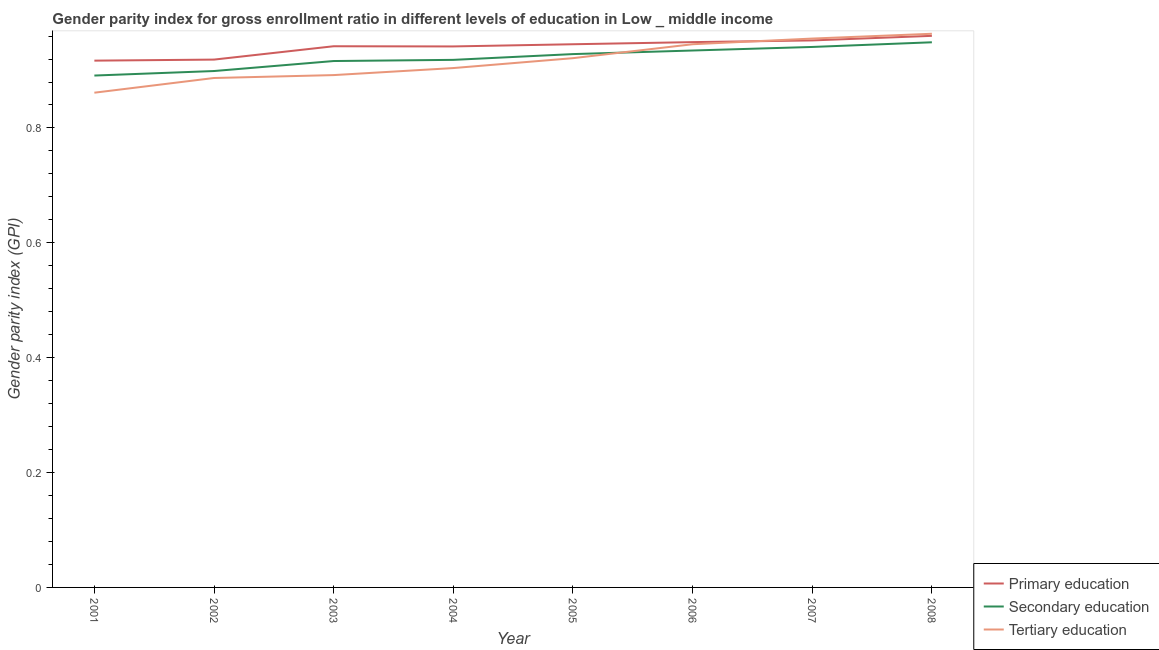Is the number of lines equal to the number of legend labels?
Your answer should be very brief. Yes. What is the gender parity index in secondary education in 2005?
Offer a terse response. 0.93. Across all years, what is the maximum gender parity index in tertiary education?
Ensure brevity in your answer.  0.96. Across all years, what is the minimum gender parity index in secondary education?
Your response must be concise. 0.89. What is the total gender parity index in primary education in the graph?
Your answer should be very brief. 7.53. What is the difference between the gender parity index in tertiary education in 2001 and that in 2006?
Your answer should be compact. -0.08. What is the difference between the gender parity index in primary education in 2004 and the gender parity index in tertiary education in 2005?
Give a very brief answer. 0.02. What is the average gender parity index in tertiary education per year?
Provide a short and direct response. 0.92. In the year 2007, what is the difference between the gender parity index in primary education and gender parity index in secondary education?
Make the answer very short. 0.01. In how many years, is the gender parity index in secondary education greater than 0.2?
Your response must be concise. 8. What is the ratio of the gender parity index in primary education in 2001 to that in 2008?
Your answer should be compact. 0.96. Is the gender parity index in secondary education in 2004 less than that in 2008?
Make the answer very short. Yes. What is the difference between the highest and the second highest gender parity index in primary education?
Your answer should be compact. 0.01. What is the difference between the highest and the lowest gender parity index in secondary education?
Your response must be concise. 0.06. In how many years, is the gender parity index in primary education greater than the average gender parity index in primary education taken over all years?
Ensure brevity in your answer.  6. Is the sum of the gender parity index in tertiary education in 2001 and 2005 greater than the maximum gender parity index in secondary education across all years?
Provide a short and direct response. Yes. Is it the case that in every year, the sum of the gender parity index in primary education and gender parity index in secondary education is greater than the gender parity index in tertiary education?
Your response must be concise. Yes. Is the gender parity index in secondary education strictly greater than the gender parity index in tertiary education over the years?
Offer a terse response. No. Is the gender parity index in tertiary education strictly less than the gender parity index in primary education over the years?
Offer a very short reply. No. How many lines are there?
Your answer should be very brief. 3. Are the values on the major ticks of Y-axis written in scientific E-notation?
Your answer should be very brief. No. Does the graph contain grids?
Your answer should be compact. No. Where does the legend appear in the graph?
Give a very brief answer. Bottom right. How are the legend labels stacked?
Provide a short and direct response. Vertical. What is the title of the graph?
Your response must be concise. Gender parity index for gross enrollment ratio in different levels of education in Low _ middle income. What is the label or title of the Y-axis?
Your answer should be very brief. Gender parity index (GPI). What is the Gender parity index (GPI) in Primary education in 2001?
Keep it short and to the point. 0.92. What is the Gender parity index (GPI) of Secondary education in 2001?
Keep it short and to the point. 0.89. What is the Gender parity index (GPI) of Tertiary education in 2001?
Your answer should be compact. 0.86. What is the Gender parity index (GPI) in Primary education in 2002?
Offer a terse response. 0.92. What is the Gender parity index (GPI) of Secondary education in 2002?
Make the answer very short. 0.9. What is the Gender parity index (GPI) in Tertiary education in 2002?
Make the answer very short. 0.89. What is the Gender parity index (GPI) in Primary education in 2003?
Provide a short and direct response. 0.94. What is the Gender parity index (GPI) in Secondary education in 2003?
Give a very brief answer. 0.92. What is the Gender parity index (GPI) of Tertiary education in 2003?
Your response must be concise. 0.89. What is the Gender parity index (GPI) of Primary education in 2004?
Make the answer very short. 0.94. What is the Gender parity index (GPI) in Secondary education in 2004?
Give a very brief answer. 0.92. What is the Gender parity index (GPI) in Tertiary education in 2004?
Your response must be concise. 0.9. What is the Gender parity index (GPI) in Primary education in 2005?
Ensure brevity in your answer.  0.95. What is the Gender parity index (GPI) of Secondary education in 2005?
Make the answer very short. 0.93. What is the Gender parity index (GPI) of Tertiary education in 2005?
Provide a short and direct response. 0.92. What is the Gender parity index (GPI) in Primary education in 2006?
Ensure brevity in your answer.  0.95. What is the Gender parity index (GPI) of Secondary education in 2006?
Ensure brevity in your answer.  0.93. What is the Gender parity index (GPI) of Tertiary education in 2006?
Your answer should be compact. 0.95. What is the Gender parity index (GPI) in Primary education in 2007?
Provide a succinct answer. 0.95. What is the Gender parity index (GPI) in Secondary education in 2007?
Your answer should be compact. 0.94. What is the Gender parity index (GPI) of Tertiary education in 2007?
Ensure brevity in your answer.  0.96. What is the Gender parity index (GPI) of Primary education in 2008?
Keep it short and to the point. 0.96. What is the Gender parity index (GPI) in Secondary education in 2008?
Provide a short and direct response. 0.95. What is the Gender parity index (GPI) in Tertiary education in 2008?
Offer a very short reply. 0.96. Across all years, what is the maximum Gender parity index (GPI) of Primary education?
Offer a terse response. 0.96. Across all years, what is the maximum Gender parity index (GPI) in Secondary education?
Provide a short and direct response. 0.95. Across all years, what is the maximum Gender parity index (GPI) of Tertiary education?
Your answer should be compact. 0.96. Across all years, what is the minimum Gender parity index (GPI) in Primary education?
Provide a short and direct response. 0.92. Across all years, what is the minimum Gender parity index (GPI) in Secondary education?
Ensure brevity in your answer.  0.89. Across all years, what is the minimum Gender parity index (GPI) in Tertiary education?
Your answer should be compact. 0.86. What is the total Gender parity index (GPI) of Primary education in the graph?
Give a very brief answer. 7.53. What is the total Gender parity index (GPI) of Secondary education in the graph?
Give a very brief answer. 7.38. What is the total Gender parity index (GPI) in Tertiary education in the graph?
Provide a short and direct response. 7.33. What is the difference between the Gender parity index (GPI) in Primary education in 2001 and that in 2002?
Make the answer very short. -0. What is the difference between the Gender parity index (GPI) in Secondary education in 2001 and that in 2002?
Keep it short and to the point. -0.01. What is the difference between the Gender parity index (GPI) in Tertiary education in 2001 and that in 2002?
Offer a very short reply. -0.03. What is the difference between the Gender parity index (GPI) in Primary education in 2001 and that in 2003?
Give a very brief answer. -0.03. What is the difference between the Gender parity index (GPI) of Secondary education in 2001 and that in 2003?
Your answer should be very brief. -0.03. What is the difference between the Gender parity index (GPI) in Tertiary education in 2001 and that in 2003?
Provide a short and direct response. -0.03. What is the difference between the Gender parity index (GPI) of Primary education in 2001 and that in 2004?
Give a very brief answer. -0.02. What is the difference between the Gender parity index (GPI) in Secondary education in 2001 and that in 2004?
Provide a succinct answer. -0.03. What is the difference between the Gender parity index (GPI) in Tertiary education in 2001 and that in 2004?
Offer a terse response. -0.04. What is the difference between the Gender parity index (GPI) of Primary education in 2001 and that in 2005?
Offer a very short reply. -0.03. What is the difference between the Gender parity index (GPI) in Secondary education in 2001 and that in 2005?
Offer a terse response. -0.04. What is the difference between the Gender parity index (GPI) in Tertiary education in 2001 and that in 2005?
Your answer should be compact. -0.06. What is the difference between the Gender parity index (GPI) of Primary education in 2001 and that in 2006?
Your answer should be very brief. -0.03. What is the difference between the Gender parity index (GPI) of Secondary education in 2001 and that in 2006?
Provide a succinct answer. -0.04. What is the difference between the Gender parity index (GPI) in Tertiary education in 2001 and that in 2006?
Offer a terse response. -0.08. What is the difference between the Gender parity index (GPI) of Primary education in 2001 and that in 2007?
Your answer should be very brief. -0.04. What is the difference between the Gender parity index (GPI) in Secondary education in 2001 and that in 2007?
Provide a succinct answer. -0.05. What is the difference between the Gender parity index (GPI) in Tertiary education in 2001 and that in 2007?
Your response must be concise. -0.09. What is the difference between the Gender parity index (GPI) in Primary education in 2001 and that in 2008?
Your response must be concise. -0.04. What is the difference between the Gender parity index (GPI) of Secondary education in 2001 and that in 2008?
Ensure brevity in your answer.  -0.06. What is the difference between the Gender parity index (GPI) in Tertiary education in 2001 and that in 2008?
Offer a very short reply. -0.1. What is the difference between the Gender parity index (GPI) of Primary education in 2002 and that in 2003?
Your response must be concise. -0.02. What is the difference between the Gender parity index (GPI) of Secondary education in 2002 and that in 2003?
Offer a very short reply. -0.02. What is the difference between the Gender parity index (GPI) of Tertiary education in 2002 and that in 2003?
Ensure brevity in your answer.  -0.01. What is the difference between the Gender parity index (GPI) in Primary education in 2002 and that in 2004?
Give a very brief answer. -0.02. What is the difference between the Gender parity index (GPI) in Secondary education in 2002 and that in 2004?
Your answer should be very brief. -0.02. What is the difference between the Gender parity index (GPI) of Tertiary education in 2002 and that in 2004?
Provide a succinct answer. -0.02. What is the difference between the Gender parity index (GPI) in Primary education in 2002 and that in 2005?
Ensure brevity in your answer.  -0.03. What is the difference between the Gender parity index (GPI) of Secondary education in 2002 and that in 2005?
Offer a very short reply. -0.03. What is the difference between the Gender parity index (GPI) of Tertiary education in 2002 and that in 2005?
Provide a succinct answer. -0.03. What is the difference between the Gender parity index (GPI) of Primary education in 2002 and that in 2006?
Keep it short and to the point. -0.03. What is the difference between the Gender parity index (GPI) in Secondary education in 2002 and that in 2006?
Ensure brevity in your answer.  -0.04. What is the difference between the Gender parity index (GPI) of Tertiary education in 2002 and that in 2006?
Give a very brief answer. -0.06. What is the difference between the Gender parity index (GPI) of Primary education in 2002 and that in 2007?
Your response must be concise. -0.03. What is the difference between the Gender parity index (GPI) of Secondary education in 2002 and that in 2007?
Your response must be concise. -0.04. What is the difference between the Gender parity index (GPI) in Tertiary education in 2002 and that in 2007?
Offer a very short reply. -0.07. What is the difference between the Gender parity index (GPI) of Primary education in 2002 and that in 2008?
Give a very brief answer. -0.04. What is the difference between the Gender parity index (GPI) in Secondary education in 2002 and that in 2008?
Your response must be concise. -0.05. What is the difference between the Gender parity index (GPI) of Tertiary education in 2002 and that in 2008?
Make the answer very short. -0.08. What is the difference between the Gender parity index (GPI) of Primary education in 2003 and that in 2004?
Provide a short and direct response. 0. What is the difference between the Gender parity index (GPI) in Secondary education in 2003 and that in 2004?
Provide a succinct answer. -0. What is the difference between the Gender parity index (GPI) in Tertiary education in 2003 and that in 2004?
Give a very brief answer. -0.01. What is the difference between the Gender parity index (GPI) in Primary education in 2003 and that in 2005?
Offer a very short reply. -0. What is the difference between the Gender parity index (GPI) of Secondary education in 2003 and that in 2005?
Offer a terse response. -0.01. What is the difference between the Gender parity index (GPI) of Tertiary education in 2003 and that in 2005?
Give a very brief answer. -0.03. What is the difference between the Gender parity index (GPI) in Primary education in 2003 and that in 2006?
Provide a short and direct response. -0.01. What is the difference between the Gender parity index (GPI) in Secondary education in 2003 and that in 2006?
Provide a succinct answer. -0.02. What is the difference between the Gender parity index (GPI) of Tertiary education in 2003 and that in 2006?
Your answer should be very brief. -0.05. What is the difference between the Gender parity index (GPI) of Primary education in 2003 and that in 2007?
Your answer should be very brief. -0.01. What is the difference between the Gender parity index (GPI) in Secondary education in 2003 and that in 2007?
Offer a very short reply. -0.02. What is the difference between the Gender parity index (GPI) of Tertiary education in 2003 and that in 2007?
Offer a terse response. -0.06. What is the difference between the Gender parity index (GPI) of Primary education in 2003 and that in 2008?
Provide a succinct answer. -0.02. What is the difference between the Gender parity index (GPI) of Secondary education in 2003 and that in 2008?
Your response must be concise. -0.03. What is the difference between the Gender parity index (GPI) of Tertiary education in 2003 and that in 2008?
Make the answer very short. -0.07. What is the difference between the Gender parity index (GPI) of Primary education in 2004 and that in 2005?
Offer a very short reply. -0. What is the difference between the Gender parity index (GPI) in Secondary education in 2004 and that in 2005?
Your answer should be compact. -0.01. What is the difference between the Gender parity index (GPI) in Tertiary education in 2004 and that in 2005?
Your response must be concise. -0.02. What is the difference between the Gender parity index (GPI) of Primary education in 2004 and that in 2006?
Offer a very short reply. -0.01. What is the difference between the Gender parity index (GPI) in Secondary education in 2004 and that in 2006?
Provide a short and direct response. -0.02. What is the difference between the Gender parity index (GPI) of Tertiary education in 2004 and that in 2006?
Your answer should be compact. -0.04. What is the difference between the Gender parity index (GPI) in Primary education in 2004 and that in 2007?
Offer a terse response. -0.01. What is the difference between the Gender parity index (GPI) in Secondary education in 2004 and that in 2007?
Keep it short and to the point. -0.02. What is the difference between the Gender parity index (GPI) of Tertiary education in 2004 and that in 2007?
Provide a short and direct response. -0.05. What is the difference between the Gender parity index (GPI) in Primary education in 2004 and that in 2008?
Your answer should be compact. -0.02. What is the difference between the Gender parity index (GPI) of Secondary education in 2004 and that in 2008?
Give a very brief answer. -0.03. What is the difference between the Gender parity index (GPI) of Tertiary education in 2004 and that in 2008?
Your answer should be very brief. -0.06. What is the difference between the Gender parity index (GPI) in Primary education in 2005 and that in 2006?
Your answer should be very brief. -0. What is the difference between the Gender parity index (GPI) of Secondary education in 2005 and that in 2006?
Ensure brevity in your answer.  -0.01. What is the difference between the Gender parity index (GPI) of Tertiary education in 2005 and that in 2006?
Give a very brief answer. -0.02. What is the difference between the Gender parity index (GPI) in Primary education in 2005 and that in 2007?
Your response must be concise. -0.01. What is the difference between the Gender parity index (GPI) in Secondary education in 2005 and that in 2007?
Provide a succinct answer. -0.01. What is the difference between the Gender parity index (GPI) of Tertiary education in 2005 and that in 2007?
Your answer should be very brief. -0.03. What is the difference between the Gender parity index (GPI) in Primary education in 2005 and that in 2008?
Your answer should be compact. -0.01. What is the difference between the Gender parity index (GPI) of Secondary education in 2005 and that in 2008?
Offer a very short reply. -0.02. What is the difference between the Gender parity index (GPI) of Tertiary education in 2005 and that in 2008?
Your response must be concise. -0.04. What is the difference between the Gender parity index (GPI) in Primary education in 2006 and that in 2007?
Provide a short and direct response. -0. What is the difference between the Gender parity index (GPI) in Secondary education in 2006 and that in 2007?
Give a very brief answer. -0.01. What is the difference between the Gender parity index (GPI) in Tertiary education in 2006 and that in 2007?
Your answer should be compact. -0.01. What is the difference between the Gender parity index (GPI) in Primary education in 2006 and that in 2008?
Offer a terse response. -0.01. What is the difference between the Gender parity index (GPI) of Secondary education in 2006 and that in 2008?
Your answer should be compact. -0.01. What is the difference between the Gender parity index (GPI) in Tertiary education in 2006 and that in 2008?
Make the answer very short. -0.02. What is the difference between the Gender parity index (GPI) in Primary education in 2007 and that in 2008?
Your answer should be compact. -0.01. What is the difference between the Gender parity index (GPI) of Secondary education in 2007 and that in 2008?
Ensure brevity in your answer.  -0.01. What is the difference between the Gender parity index (GPI) in Tertiary education in 2007 and that in 2008?
Ensure brevity in your answer.  -0.01. What is the difference between the Gender parity index (GPI) in Primary education in 2001 and the Gender parity index (GPI) in Secondary education in 2002?
Make the answer very short. 0.02. What is the difference between the Gender parity index (GPI) in Primary education in 2001 and the Gender parity index (GPI) in Tertiary education in 2002?
Ensure brevity in your answer.  0.03. What is the difference between the Gender parity index (GPI) of Secondary education in 2001 and the Gender parity index (GPI) of Tertiary education in 2002?
Your response must be concise. 0. What is the difference between the Gender parity index (GPI) of Primary education in 2001 and the Gender parity index (GPI) of Secondary education in 2003?
Give a very brief answer. 0. What is the difference between the Gender parity index (GPI) of Primary education in 2001 and the Gender parity index (GPI) of Tertiary education in 2003?
Your answer should be compact. 0.03. What is the difference between the Gender parity index (GPI) of Secondary education in 2001 and the Gender parity index (GPI) of Tertiary education in 2003?
Your answer should be compact. -0. What is the difference between the Gender parity index (GPI) in Primary education in 2001 and the Gender parity index (GPI) in Secondary education in 2004?
Your answer should be very brief. -0. What is the difference between the Gender parity index (GPI) in Primary education in 2001 and the Gender parity index (GPI) in Tertiary education in 2004?
Keep it short and to the point. 0.01. What is the difference between the Gender parity index (GPI) in Secondary education in 2001 and the Gender parity index (GPI) in Tertiary education in 2004?
Your answer should be very brief. -0.01. What is the difference between the Gender parity index (GPI) of Primary education in 2001 and the Gender parity index (GPI) of Secondary education in 2005?
Provide a short and direct response. -0.01. What is the difference between the Gender parity index (GPI) of Primary education in 2001 and the Gender parity index (GPI) of Tertiary education in 2005?
Your answer should be compact. -0. What is the difference between the Gender parity index (GPI) in Secondary education in 2001 and the Gender parity index (GPI) in Tertiary education in 2005?
Your answer should be very brief. -0.03. What is the difference between the Gender parity index (GPI) of Primary education in 2001 and the Gender parity index (GPI) of Secondary education in 2006?
Your answer should be very brief. -0.02. What is the difference between the Gender parity index (GPI) of Primary education in 2001 and the Gender parity index (GPI) of Tertiary education in 2006?
Provide a short and direct response. -0.03. What is the difference between the Gender parity index (GPI) of Secondary education in 2001 and the Gender parity index (GPI) of Tertiary education in 2006?
Your answer should be very brief. -0.05. What is the difference between the Gender parity index (GPI) of Primary education in 2001 and the Gender parity index (GPI) of Secondary education in 2007?
Offer a very short reply. -0.02. What is the difference between the Gender parity index (GPI) in Primary education in 2001 and the Gender parity index (GPI) in Tertiary education in 2007?
Provide a succinct answer. -0.04. What is the difference between the Gender parity index (GPI) of Secondary education in 2001 and the Gender parity index (GPI) of Tertiary education in 2007?
Your answer should be compact. -0.06. What is the difference between the Gender parity index (GPI) of Primary education in 2001 and the Gender parity index (GPI) of Secondary education in 2008?
Keep it short and to the point. -0.03. What is the difference between the Gender parity index (GPI) of Primary education in 2001 and the Gender parity index (GPI) of Tertiary education in 2008?
Provide a short and direct response. -0.05. What is the difference between the Gender parity index (GPI) of Secondary education in 2001 and the Gender parity index (GPI) of Tertiary education in 2008?
Make the answer very short. -0.07. What is the difference between the Gender parity index (GPI) in Primary education in 2002 and the Gender parity index (GPI) in Secondary education in 2003?
Your response must be concise. 0. What is the difference between the Gender parity index (GPI) in Primary education in 2002 and the Gender parity index (GPI) in Tertiary education in 2003?
Provide a succinct answer. 0.03. What is the difference between the Gender parity index (GPI) in Secondary education in 2002 and the Gender parity index (GPI) in Tertiary education in 2003?
Your response must be concise. 0.01. What is the difference between the Gender parity index (GPI) of Primary education in 2002 and the Gender parity index (GPI) of Secondary education in 2004?
Keep it short and to the point. 0. What is the difference between the Gender parity index (GPI) in Primary education in 2002 and the Gender parity index (GPI) in Tertiary education in 2004?
Provide a short and direct response. 0.01. What is the difference between the Gender parity index (GPI) of Secondary education in 2002 and the Gender parity index (GPI) of Tertiary education in 2004?
Your answer should be very brief. -0.01. What is the difference between the Gender parity index (GPI) of Primary education in 2002 and the Gender parity index (GPI) of Secondary education in 2005?
Your answer should be compact. -0.01. What is the difference between the Gender parity index (GPI) of Primary education in 2002 and the Gender parity index (GPI) of Tertiary education in 2005?
Keep it short and to the point. -0. What is the difference between the Gender parity index (GPI) in Secondary education in 2002 and the Gender parity index (GPI) in Tertiary education in 2005?
Provide a short and direct response. -0.02. What is the difference between the Gender parity index (GPI) of Primary education in 2002 and the Gender parity index (GPI) of Secondary education in 2006?
Your answer should be very brief. -0.02. What is the difference between the Gender parity index (GPI) in Primary education in 2002 and the Gender parity index (GPI) in Tertiary education in 2006?
Provide a succinct answer. -0.03. What is the difference between the Gender parity index (GPI) of Secondary education in 2002 and the Gender parity index (GPI) of Tertiary education in 2006?
Your response must be concise. -0.05. What is the difference between the Gender parity index (GPI) in Primary education in 2002 and the Gender parity index (GPI) in Secondary education in 2007?
Make the answer very short. -0.02. What is the difference between the Gender parity index (GPI) of Primary education in 2002 and the Gender parity index (GPI) of Tertiary education in 2007?
Offer a terse response. -0.04. What is the difference between the Gender parity index (GPI) of Secondary education in 2002 and the Gender parity index (GPI) of Tertiary education in 2007?
Your answer should be compact. -0.06. What is the difference between the Gender parity index (GPI) in Primary education in 2002 and the Gender parity index (GPI) in Secondary education in 2008?
Provide a succinct answer. -0.03. What is the difference between the Gender parity index (GPI) in Primary education in 2002 and the Gender parity index (GPI) in Tertiary education in 2008?
Give a very brief answer. -0.04. What is the difference between the Gender parity index (GPI) in Secondary education in 2002 and the Gender parity index (GPI) in Tertiary education in 2008?
Provide a short and direct response. -0.06. What is the difference between the Gender parity index (GPI) of Primary education in 2003 and the Gender parity index (GPI) of Secondary education in 2004?
Make the answer very short. 0.02. What is the difference between the Gender parity index (GPI) of Primary education in 2003 and the Gender parity index (GPI) of Tertiary education in 2004?
Make the answer very short. 0.04. What is the difference between the Gender parity index (GPI) in Secondary education in 2003 and the Gender parity index (GPI) in Tertiary education in 2004?
Offer a very short reply. 0.01. What is the difference between the Gender parity index (GPI) of Primary education in 2003 and the Gender parity index (GPI) of Secondary education in 2005?
Your answer should be compact. 0.01. What is the difference between the Gender parity index (GPI) of Primary education in 2003 and the Gender parity index (GPI) of Tertiary education in 2005?
Provide a succinct answer. 0.02. What is the difference between the Gender parity index (GPI) in Secondary education in 2003 and the Gender parity index (GPI) in Tertiary education in 2005?
Make the answer very short. -0.01. What is the difference between the Gender parity index (GPI) in Primary education in 2003 and the Gender parity index (GPI) in Secondary education in 2006?
Provide a succinct answer. 0.01. What is the difference between the Gender parity index (GPI) in Primary education in 2003 and the Gender parity index (GPI) in Tertiary education in 2006?
Your answer should be very brief. -0. What is the difference between the Gender parity index (GPI) of Secondary education in 2003 and the Gender parity index (GPI) of Tertiary education in 2006?
Ensure brevity in your answer.  -0.03. What is the difference between the Gender parity index (GPI) of Primary education in 2003 and the Gender parity index (GPI) of Secondary education in 2007?
Offer a very short reply. 0. What is the difference between the Gender parity index (GPI) in Primary education in 2003 and the Gender parity index (GPI) in Tertiary education in 2007?
Keep it short and to the point. -0.01. What is the difference between the Gender parity index (GPI) in Secondary education in 2003 and the Gender parity index (GPI) in Tertiary education in 2007?
Make the answer very short. -0.04. What is the difference between the Gender parity index (GPI) in Primary education in 2003 and the Gender parity index (GPI) in Secondary education in 2008?
Ensure brevity in your answer.  -0.01. What is the difference between the Gender parity index (GPI) of Primary education in 2003 and the Gender parity index (GPI) of Tertiary education in 2008?
Offer a terse response. -0.02. What is the difference between the Gender parity index (GPI) in Secondary education in 2003 and the Gender parity index (GPI) in Tertiary education in 2008?
Give a very brief answer. -0.05. What is the difference between the Gender parity index (GPI) of Primary education in 2004 and the Gender parity index (GPI) of Secondary education in 2005?
Your response must be concise. 0.01. What is the difference between the Gender parity index (GPI) in Primary education in 2004 and the Gender parity index (GPI) in Tertiary education in 2005?
Offer a very short reply. 0.02. What is the difference between the Gender parity index (GPI) in Secondary education in 2004 and the Gender parity index (GPI) in Tertiary education in 2005?
Provide a succinct answer. -0. What is the difference between the Gender parity index (GPI) of Primary education in 2004 and the Gender parity index (GPI) of Secondary education in 2006?
Ensure brevity in your answer.  0.01. What is the difference between the Gender parity index (GPI) in Primary education in 2004 and the Gender parity index (GPI) in Tertiary education in 2006?
Make the answer very short. -0. What is the difference between the Gender parity index (GPI) of Secondary education in 2004 and the Gender parity index (GPI) of Tertiary education in 2006?
Provide a short and direct response. -0.03. What is the difference between the Gender parity index (GPI) of Primary education in 2004 and the Gender parity index (GPI) of Secondary education in 2007?
Keep it short and to the point. 0. What is the difference between the Gender parity index (GPI) in Primary education in 2004 and the Gender parity index (GPI) in Tertiary education in 2007?
Give a very brief answer. -0.01. What is the difference between the Gender parity index (GPI) of Secondary education in 2004 and the Gender parity index (GPI) of Tertiary education in 2007?
Make the answer very short. -0.04. What is the difference between the Gender parity index (GPI) in Primary education in 2004 and the Gender parity index (GPI) in Secondary education in 2008?
Provide a succinct answer. -0.01. What is the difference between the Gender parity index (GPI) of Primary education in 2004 and the Gender parity index (GPI) of Tertiary education in 2008?
Your answer should be very brief. -0.02. What is the difference between the Gender parity index (GPI) in Secondary education in 2004 and the Gender parity index (GPI) in Tertiary education in 2008?
Provide a succinct answer. -0.05. What is the difference between the Gender parity index (GPI) of Primary education in 2005 and the Gender parity index (GPI) of Secondary education in 2006?
Make the answer very short. 0.01. What is the difference between the Gender parity index (GPI) in Secondary education in 2005 and the Gender parity index (GPI) in Tertiary education in 2006?
Provide a succinct answer. -0.02. What is the difference between the Gender parity index (GPI) in Primary education in 2005 and the Gender parity index (GPI) in Secondary education in 2007?
Provide a succinct answer. 0. What is the difference between the Gender parity index (GPI) of Primary education in 2005 and the Gender parity index (GPI) of Tertiary education in 2007?
Your answer should be very brief. -0.01. What is the difference between the Gender parity index (GPI) of Secondary education in 2005 and the Gender parity index (GPI) of Tertiary education in 2007?
Offer a terse response. -0.03. What is the difference between the Gender parity index (GPI) of Primary education in 2005 and the Gender parity index (GPI) of Secondary education in 2008?
Your answer should be compact. -0. What is the difference between the Gender parity index (GPI) of Primary education in 2005 and the Gender parity index (GPI) of Tertiary education in 2008?
Provide a succinct answer. -0.02. What is the difference between the Gender parity index (GPI) in Secondary education in 2005 and the Gender parity index (GPI) in Tertiary education in 2008?
Offer a very short reply. -0.04. What is the difference between the Gender parity index (GPI) of Primary education in 2006 and the Gender parity index (GPI) of Secondary education in 2007?
Ensure brevity in your answer.  0.01. What is the difference between the Gender parity index (GPI) in Primary education in 2006 and the Gender parity index (GPI) in Tertiary education in 2007?
Your answer should be compact. -0.01. What is the difference between the Gender parity index (GPI) in Secondary education in 2006 and the Gender parity index (GPI) in Tertiary education in 2007?
Offer a terse response. -0.02. What is the difference between the Gender parity index (GPI) of Primary education in 2006 and the Gender parity index (GPI) of Tertiary education in 2008?
Your response must be concise. -0.01. What is the difference between the Gender parity index (GPI) of Secondary education in 2006 and the Gender parity index (GPI) of Tertiary education in 2008?
Your answer should be very brief. -0.03. What is the difference between the Gender parity index (GPI) in Primary education in 2007 and the Gender parity index (GPI) in Secondary education in 2008?
Give a very brief answer. 0. What is the difference between the Gender parity index (GPI) of Primary education in 2007 and the Gender parity index (GPI) of Tertiary education in 2008?
Keep it short and to the point. -0.01. What is the difference between the Gender parity index (GPI) in Secondary education in 2007 and the Gender parity index (GPI) in Tertiary education in 2008?
Ensure brevity in your answer.  -0.02. What is the average Gender parity index (GPI) of Primary education per year?
Keep it short and to the point. 0.94. What is the average Gender parity index (GPI) in Secondary education per year?
Offer a very short reply. 0.92. What is the average Gender parity index (GPI) of Tertiary education per year?
Ensure brevity in your answer.  0.92. In the year 2001, what is the difference between the Gender parity index (GPI) of Primary education and Gender parity index (GPI) of Secondary education?
Provide a succinct answer. 0.03. In the year 2001, what is the difference between the Gender parity index (GPI) in Primary education and Gender parity index (GPI) in Tertiary education?
Your response must be concise. 0.06. In the year 2001, what is the difference between the Gender parity index (GPI) in Secondary education and Gender parity index (GPI) in Tertiary education?
Your answer should be very brief. 0.03. In the year 2002, what is the difference between the Gender parity index (GPI) of Primary education and Gender parity index (GPI) of Secondary education?
Your response must be concise. 0.02. In the year 2002, what is the difference between the Gender parity index (GPI) of Primary education and Gender parity index (GPI) of Tertiary education?
Provide a succinct answer. 0.03. In the year 2002, what is the difference between the Gender parity index (GPI) in Secondary education and Gender parity index (GPI) in Tertiary education?
Offer a terse response. 0.01. In the year 2003, what is the difference between the Gender parity index (GPI) in Primary education and Gender parity index (GPI) in Secondary education?
Provide a succinct answer. 0.03. In the year 2003, what is the difference between the Gender parity index (GPI) of Primary education and Gender parity index (GPI) of Tertiary education?
Offer a very short reply. 0.05. In the year 2003, what is the difference between the Gender parity index (GPI) of Secondary education and Gender parity index (GPI) of Tertiary education?
Keep it short and to the point. 0.02. In the year 2004, what is the difference between the Gender parity index (GPI) of Primary education and Gender parity index (GPI) of Secondary education?
Provide a succinct answer. 0.02. In the year 2004, what is the difference between the Gender parity index (GPI) in Primary education and Gender parity index (GPI) in Tertiary education?
Offer a very short reply. 0.04. In the year 2004, what is the difference between the Gender parity index (GPI) of Secondary education and Gender parity index (GPI) of Tertiary education?
Provide a succinct answer. 0.01. In the year 2005, what is the difference between the Gender parity index (GPI) in Primary education and Gender parity index (GPI) in Secondary education?
Ensure brevity in your answer.  0.02. In the year 2005, what is the difference between the Gender parity index (GPI) in Primary education and Gender parity index (GPI) in Tertiary education?
Your answer should be very brief. 0.02. In the year 2005, what is the difference between the Gender parity index (GPI) of Secondary education and Gender parity index (GPI) of Tertiary education?
Make the answer very short. 0.01. In the year 2006, what is the difference between the Gender parity index (GPI) of Primary education and Gender parity index (GPI) of Secondary education?
Offer a terse response. 0.01. In the year 2006, what is the difference between the Gender parity index (GPI) of Primary education and Gender parity index (GPI) of Tertiary education?
Ensure brevity in your answer.  0. In the year 2006, what is the difference between the Gender parity index (GPI) of Secondary education and Gender parity index (GPI) of Tertiary education?
Your response must be concise. -0.01. In the year 2007, what is the difference between the Gender parity index (GPI) in Primary education and Gender parity index (GPI) in Secondary education?
Give a very brief answer. 0.01. In the year 2007, what is the difference between the Gender parity index (GPI) in Primary education and Gender parity index (GPI) in Tertiary education?
Ensure brevity in your answer.  -0. In the year 2007, what is the difference between the Gender parity index (GPI) of Secondary education and Gender parity index (GPI) of Tertiary education?
Your response must be concise. -0.01. In the year 2008, what is the difference between the Gender parity index (GPI) in Primary education and Gender parity index (GPI) in Secondary education?
Your answer should be very brief. 0.01. In the year 2008, what is the difference between the Gender parity index (GPI) of Primary education and Gender parity index (GPI) of Tertiary education?
Provide a succinct answer. -0. In the year 2008, what is the difference between the Gender parity index (GPI) of Secondary education and Gender parity index (GPI) of Tertiary education?
Offer a very short reply. -0.01. What is the ratio of the Gender parity index (GPI) in Secondary education in 2001 to that in 2002?
Your response must be concise. 0.99. What is the ratio of the Gender parity index (GPI) in Tertiary education in 2001 to that in 2002?
Offer a very short reply. 0.97. What is the ratio of the Gender parity index (GPI) in Primary education in 2001 to that in 2003?
Your response must be concise. 0.97. What is the ratio of the Gender parity index (GPI) of Secondary education in 2001 to that in 2003?
Offer a terse response. 0.97. What is the ratio of the Gender parity index (GPI) of Tertiary education in 2001 to that in 2003?
Provide a short and direct response. 0.97. What is the ratio of the Gender parity index (GPI) in Primary education in 2001 to that in 2004?
Provide a short and direct response. 0.97. What is the ratio of the Gender parity index (GPI) of Secondary education in 2001 to that in 2004?
Your answer should be compact. 0.97. What is the ratio of the Gender parity index (GPI) of Tertiary education in 2001 to that in 2004?
Your response must be concise. 0.95. What is the ratio of the Gender parity index (GPI) of Primary education in 2001 to that in 2005?
Provide a short and direct response. 0.97. What is the ratio of the Gender parity index (GPI) in Secondary education in 2001 to that in 2005?
Give a very brief answer. 0.96. What is the ratio of the Gender parity index (GPI) of Tertiary education in 2001 to that in 2005?
Your response must be concise. 0.93. What is the ratio of the Gender parity index (GPI) of Secondary education in 2001 to that in 2006?
Offer a terse response. 0.95. What is the ratio of the Gender parity index (GPI) in Tertiary education in 2001 to that in 2006?
Provide a short and direct response. 0.91. What is the ratio of the Gender parity index (GPI) in Primary education in 2001 to that in 2007?
Provide a short and direct response. 0.96. What is the ratio of the Gender parity index (GPI) of Secondary education in 2001 to that in 2007?
Offer a very short reply. 0.95. What is the ratio of the Gender parity index (GPI) in Tertiary education in 2001 to that in 2007?
Ensure brevity in your answer.  0.9. What is the ratio of the Gender parity index (GPI) in Primary education in 2001 to that in 2008?
Provide a short and direct response. 0.95. What is the ratio of the Gender parity index (GPI) of Secondary education in 2001 to that in 2008?
Your answer should be compact. 0.94. What is the ratio of the Gender parity index (GPI) of Tertiary education in 2001 to that in 2008?
Offer a terse response. 0.89. What is the ratio of the Gender parity index (GPI) in Primary education in 2002 to that in 2003?
Your answer should be compact. 0.98. What is the ratio of the Gender parity index (GPI) in Secondary education in 2002 to that in 2003?
Give a very brief answer. 0.98. What is the ratio of the Gender parity index (GPI) of Primary education in 2002 to that in 2004?
Provide a short and direct response. 0.98. What is the ratio of the Gender parity index (GPI) in Secondary education in 2002 to that in 2004?
Your answer should be very brief. 0.98. What is the ratio of the Gender parity index (GPI) of Tertiary education in 2002 to that in 2004?
Provide a short and direct response. 0.98. What is the ratio of the Gender parity index (GPI) in Primary education in 2002 to that in 2005?
Ensure brevity in your answer.  0.97. What is the ratio of the Gender parity index (GPI) in Secondary education in 2002 to that in 2005?
Offer a very short reply. 0.97. What is the ratio of the Gender parity index (GPI) in Tertiary education in 2002 to that in 2005?
Ensure brevity in your answer.  0.96. What is the ratio of the Gender parity index (GPI) of Primary education in 2002 to that in 2006?
Keep it short and to the point. 0.97. What is the ratio of the Gender parity index (GPI) of Secondary education in 2002 to that in 2006?
Make the answer very short. 0.96. What is the ratio of the Gender parity index (GPI) of Tertiary education in 2002 to that in 2006?
Provide a short and direct response. 0.94. What is the ratio of the Gender parity index (GPI) in Primary education in 2002 to that in 2007?
Offer a terse response. 0.96. What is the ratio of the Gender parity index (GPI) in Secondary education in 2002 to that in 2007?
Your response must be concise. 0.96. What is the ratio of the Gender parity index (GPI) of Tertiary education in 2002 to that in 2007?
Give a very brief answer. 0.93. What is the ratio of the Gender parity index (GPI) in Primary education in 2002 to that in 2008?
Your response must be concise. 0.96. What is the ratio of the Gender parity index (GPI) in Secondary education in 2002 to that in 2008?
Provide a short and direct response. 0.95. What is the ratio of the Gender parity index (GPI) in Tertiary education in 2002 to that in 2008?
Offer a terse response. 0.92. What is the ratio of the Gender parity index (GPI) in Secondary education in 2003 to that in 2004?
Provide a succinct answer. 1. What is the ratio of the Gender parity index (GPI) in Tertiary education in 2003 to that in 2004?
Your answer should be compact. 0.99. What is the ratio of the Gender parity index (GPI) of Primary education in 2003 to that in 2005?
Your response must be concise. 1. What is the ratio of the Gender parity index (GPI) of Secondary education in 2003 to that in 2006?
Provide a short and direct response. 0.98. What is the ratio of the Gender parity index (GPI) in Tertiary education in 2003 to that in 2006?
Offer a terse response. 0.94. What is the ratio of the Gender parity index (GPI) in Secondary education in 2003 to that in 2007?
Offer a terse response. 0.97. What is the ratio of the Gender parity index (GPI) of Tertiary education in 2003 to that in 2007?
Offer a terse response. 0.93. What is the ratio of the Gender parity index (GPI) in Primary education in 2003 to that in 2008?
Your response must be concise. 0.98. What is the ratio of the Gender parity index (GPI) of Secondary education in 2003 to that in 2008?
Give a very brief answer. 0.97. What is the ratio of the Gender parity index (GPI) of Tertiary education in 2003 to that in 2008?
Your response must be concise. 0.93. What is the ratio of the Gender parity index (GPI) of Primary education in 2004 to that in 2005?
Give a very brief answer. 1. What is the ratio of the Gender parity index (GPI) of Tertiary education in 2004 to that in 2005?
Provide a short and direct response. 0.98. What is the ratio of the Gender parity index (GPI) in Primary education in 2004 to that in 2006?
Give a very brief answer. 0.99. What is the ratio of the Gender parity index (GPI) in Secondary education in 2004 to that in 2006?
Give a very brief answer. 0.98. What is the ratio of the Gender parity index (GPI) in Tertiary education in 2004 to that in 2006?
Your answer should be very brief. 0.96. What is the ratio of the Gender parity index (GPI) in Primary education in 2004 to that in 2007?
Give a very brief answer. 0.99. What is the ratio of the Gender parity index (GPI) of Secondary education in 2004 to that in 2007?
Your response must be concise. 0.98. What is the ratio of the Gender parity index (GPI) of Tertiary education in 2004 to that in 2007?
Make the answer very short. 0.95. What is the ratio of the Gender parity index (GPI) of Primary education in 2004 to that in 2008?
Make the answer very short. 0.98. What is the ratio of the Gender parity index (GPI) of Secondary education in 2004 to that in 2008?
Keep it short and to the point. 0.97. What is the ratio of the Gender parity index (GPI) in Tertiary education in 2004 to that in 2008?
Offer a terse response. 0.94. What is the ratio of the Gender parity index (GPI) of Primary education in 2005 to that in 2006?
Provide a short and direct response. 1. What is the ratio of the Gender parity index (GPI) in Secondary education in 2005 to that in 2006?
Ensure brevity in your answer.  0.99. What is the ratio of the Gender parity index (GPI) in Tertiary education in 2005 to that in 2006?
Give a very brief answer. 0.97. What is the ratio of the Gender parity index (GPI) of Primary education in 2005 to that in 2007?
Provide a succinct answer. 0.99. What is the ratio of the Gender parity index (GPI) in Secondary education in 2005 to that in 2008?
Make the answer very short. 0.98. What is the ratio of the Gender parity index (GPI) in Tertiary education in 2005 to that in 2008?
Provide a short and direct response. 0.96. What is the ratio of the Gender parity index (GPI) in Primary education in 2006 to that in 2007?
Keep it short and to the point. 1. What is the ratio of the Gender parity index (GPI) in Secondary education in 2006 to that in 2007?
Your answer should be compact. 0.99. What is the ratio of the Gender parity index (GPI) in Tertiary education in 2006 to that in 2007?
Keep it short and to the point. 0.99. What is the ratio of the Gender parity index (GPI) of Secondary education in 2006 to that in 2008?
Keep it short and to the point. 0.98. What is the ratio of the Gender parity index (GPI) of Tertiary education in 2006 to that in 2008?
Provide a succinct answer. 0.98. What is the ratio of the Gender parity index (GPI) in Secondary education in 2007 to that in 2008?
Offer a terse response. 0.99. What is the difference between the highest and the second highest Gender parity index (GPI) of Primary education?
Offer a terse response. 0.01. What is the difference between the highest and the second highest Gender parity index (GPI) in Secondary education?
Your answer should be compact. 0.01. What is the difference between the highest and the second highest Gender parity index (GPI) in Tertiary education?
Your response must be concise. 0.01. What is the difference between the highest and the lowest Gender parity index (GPI) of Primary education?
Provide a succinct answer. 0.04. What is the difference between the highest and the lowest Gender parity index (GPI) in Secondary education?
Ensure brevity in your answer.  0.06. What is the difference between the highest and the lowest Gender parity index (GPI) of Tertiary education?
Your answer should be very brief. 0.1. 